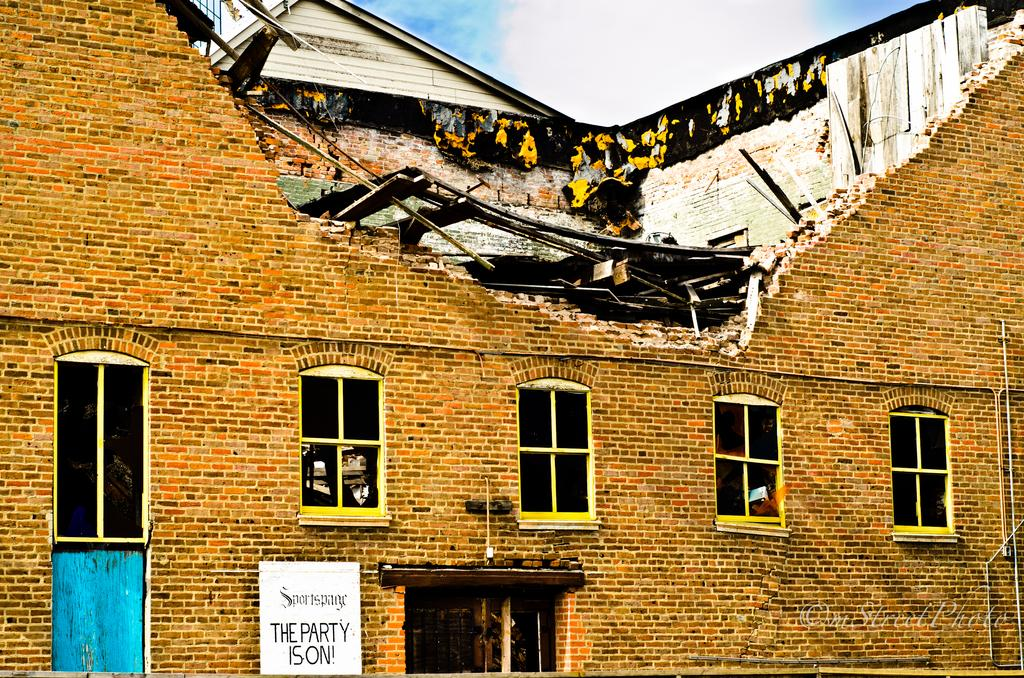What is the main subject of the image? The main subject of the image is a collapsed building. Are there any other objects or signs in the image? Yes, there is a name board in the image. What can be seen in the background of the image? The sky is visible in the background of the image. Is there any additional information about the image itself? Yes, there is a watermark on the image. How many legs can be seen on the father in the image? There is no father or legs present in the image; it features a collapsed building and a name board. What type of soap is being used to clean the collapsed building in the image? There is no soap or cleaning activity depicted in the image; it shows a collapsed building and a name board. 